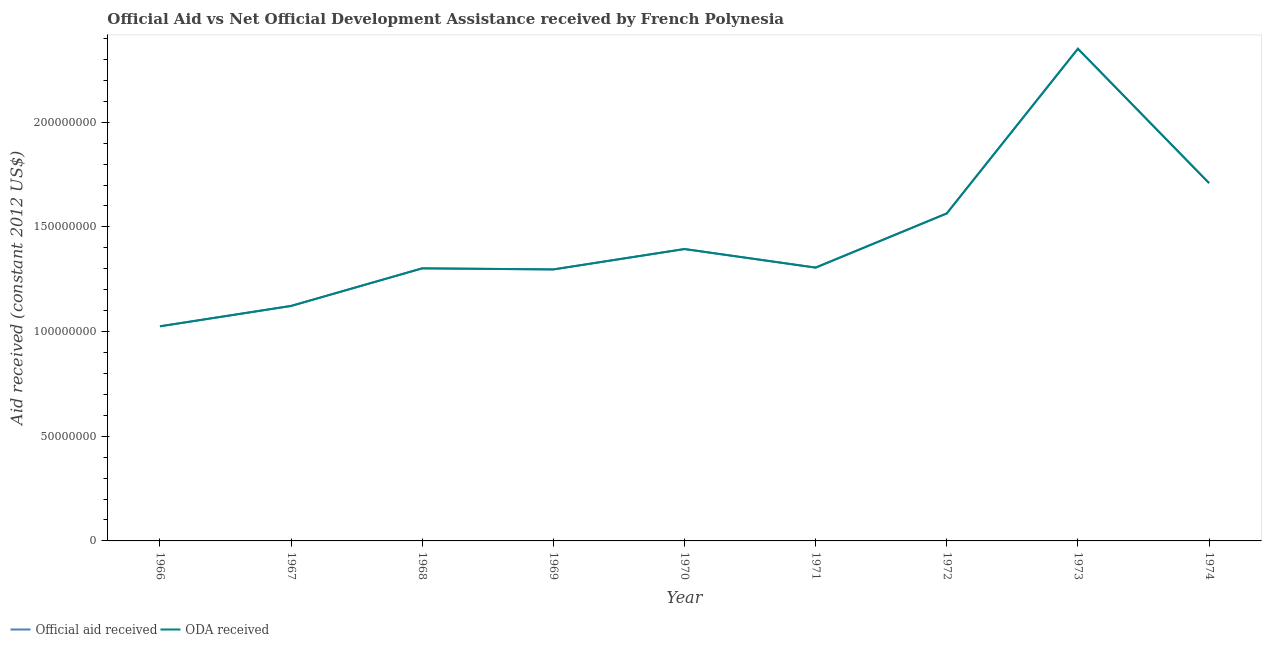How many different coloured lines are there?
Your response must be concise. 2. Does the line corresponding to official aid received intersect with the line corresponding to oda received?
Your response must be concise. Yes. What is the official aid received in 1973?
Your answer should be compact. 2.35e+08. Across all years, what is the maximum official aid received?
Offer a terse response. 2.35e+08. Across all years, what is the minimum official aid received?
Provide a succinct answer. 1.03e+08. In which year was the official aid received minimum?
Keep it short and to the point. 1966. What is the total official aid received in the graph?
Provide a short and direct response. 1.31e+09. What is the difference between the official aid received in 1969 and that in 1972?
Your response must be concise. -2.68e+07. What is the difference between the official aid received in 1969 and the oda received in 1967?
Provide a short and direct response. 1.74e+07. What is the average oda received per year?
Make the answer very short. 1.45e+08. In how many years, is the official aid received greater than 110000000 US$?
Your answer should be compact. 8. What is the ratio of the oda received in 1967 to that in 1969?
Keep it short and to the point. 0.87. Is the official aid received in 1967 less than that in 1969?
Offer a very short reply. Yes. Is the difference between the oda received in 1971 and 1974 greater than the difference between the official aid received in 1971 and 1974?
Offer a terse response. No. What is the difference between the highest and the second highest oda received?
Your answer should be compact. 6.42e+07. What is the difference between the highest and the lowest oda received?
Give a very brief answer. 1.33e+08. Is the oda received strictly greater than the official aid received over the years?
Keep it short and to the point. No. How many lines are there?
Your answer should be very brief. 2. How many years are there in the graph?
Offer a very short reply. 9. What is the difference between two consecutive major ticks on the Y-axis?
Provide a succinct answer. 5.00e+07. Are the values on the major ticks of Y-axis written in scientific E-notation?
Provide a succinct answer. No. Does the graph contain any zero values?
Provide a short and direct response. No. Does the graph contain grids?
Offer a very short reply. No. Where does the legend appear in the graph?
Provide a short and direct response. Bottom left. How many legend labels are there?
Offer a very short reply. 2. What is the title of the graph?
Ensure brevity in your answer.  Official Aid vs Net Official Development Assistance received by French Polynesia . Does "Commercial service exports" appear as one of the legend labels in the graph?
Provide a succinct answer. No. What is the label or title of the X-axis?
Provide a succinct answer. Year. What is the label or title of the Y-axis?
Your answer should be very brief. Aid received (constant 2012 US$). What is the Aid received (constant 2012 US$) of Official aid received in 1966?
Keep it short and to the point. 1.03e+08. What is the Aid received (constant 2012 US$) in ODA received in 1966?
Ensure brevity in your answer.  1.03e+08. What is the Aid received (constant 2012 US$) in Official aid received in 1967?
Offer a terse response. 1.12e+08. What is the Aid received (constant 2012 US$) in ODA received in 1967?
Offer a terse response. 1.12e+08. What is the Aid received (constant 2012 US$) in Official aid received in 1968?
Your response must be concise. 1.30e+08. What is the Aid received (constant 2012 US$) in ODA received in 1968?
Ensure brevity in your answer.  1.30e+08. What is the Aid received (constant 2012 US$) in Official aid received in 1969?
Your answer should be very brief. 1.30e+08. What is the Aid received (constant 2012 US$) in ODA received in 1969?
Your answer should be very brief. 1.30e+08. What is the Aid received (constant 2012 US$) in Official aid received in 1970?
Give a very brief answer. 1.39e+08. What is the Aid received (constant 2012 US$) in ODA received in 1970?
Provide a short and direct response. 1.39e+08. What is the Aid received (constant 2012 US$) of Official aid received in 1971?
Offer a very short reply. 1.31e+08. What is the Aid received (constant 2012 US$) in ODA received in 1971?
Give a very brief answer. 1.31e+08. What is the Aid received (constant 2012 US$) of Official aid received in 1972?
Provide a short and direct response. 1.56e+08. What is the Aid received (constant 2012 US$) in ODA received in 1972?
Give a very brief answer. 1.56e+08. What is the Aid received (constant 2012 US$) in Official aid received in 1973?
Offer a very short reply. 2.35e+08. What is the Aid received (constant 2012 US$) of ODA received in 1973?
Keep it short and to the point. 2.35e+08. What is the Aid received (constant 2012 US$) in Official aid received in 1974?
Ensure brevity in your answer.  1.71e+08. What is the Aid received (constant 2012 US$) of ODA received in 1974?
Your response must be concise. 1.71e+08. Across all years, what is the maximum Aid received (constant 2012 US$) in Official aid received?
Give a very brief answer. 2.35e+08. Across all years, what is the maximum Aid received (constant 2012 US$) of ODA received?
Your response must be concise. 2.35e+08. Across all years, what is the minimum Aid received (constant 2012 US$) in Official aid received?
Your response must be concise. 1.03e+08. Across all years, what is the minimum Aid received (constant 2012 US$) of ODA received?
Your response must be concise. 1.03e+08. What is the total Aid received (constant 2012 US$) of Official aid received in the graph?
Ensure brevity in your answer.  1.31e+09. What is the total Aid received (constant 2012 US$) in ODA received in the graph?
Keep it short and to the point. 1.31e+09. What is the difference between the Aid received (constant 2012 US$) in Official aid received in 1966 and that in 1967?
Ensure brevity in your answer.  -9.73e+06. What is the difference between the Aid received (constant 2012 US$) of ODA received in 1966 and that in 1967?
Provide a succinct answer. -9.73e+06. What is the difference between the Aid received (constant 2012 US$) in Official aid received in 1966 and that in 1968?
Keep it short and to the point. -2.77e+07. What is the difference between the Aid received (constant 2012 US$) in ODA received in 1966 and that in 1968?
Provide a short and direct response. -2.77e+07. What is the difference between the Aid received (constant 2012 US$) of Official aid received in 1966 and that in 1969?
Keep it short and to the point. -2.72e+07. What is the difference between the Aid received (constant 2012 US$) in ODA received in 1966 and that in 1969?
Keep it short and to the point. -2.72e+07. What is the difference between the Aid received (constant 2012 US$) in Official aid received in 1966 and that in 1970?
Give a very brief answer. -3.69e+07. What is the difference between the Aid received (constant 2012 US$) of ODA received in 1966 and that in 1970?
Provide a succinct answer. -3.69e+07. What is the difference between the Aid received (constant 2012 US$) of Official aid received in 1966 and that in 1971?
Keep it short and to the point. -2.80e+07. What is the difference between the Aid received (constant 2012 US$) in ODA received in 1966 and that in 1971?
Provide a succinct answer. -2.80e+07. What is the difference between the Aid received (constant 2012 US$) in Official aid received in 1966 and that in 1972?
Make the answer very short. -5.39e+07. What is the difference between the Aid received (constant 2012 US$) of ODA received in 1966 and that in 1972?
Offer a terse response. -5.39e+07. What is the difference between the Aid received (constant 2012 US$) of Official aid received in 1966 and that in 1973?
Give a very brief answer. -1.33e+08. What is the difference between the Aid received (constant 2012 US$) in ODA received in 1966 and that in 1973?
Offer a very short reply. -1.33e+08. What is the difference between the Aid received (constant 2012 US$) of Official aid received in 1966 and that in 1974?
Your answer should be very brief. -6.84e+07. What is the difference between the Aid received (constant 2012 US$) in ODA received in 1966 and that in 1974?
Your answer should be very brief. -6.84e+07. What is the difference between the Aid received (constant 2012 US$) of Official aid received in 1967 and that in 1968?
Ensure brevity in your answer.  -1.80e+07. What is the difference between the Aid received (constant 2012 US$) in ODA received in 1967 and that in 1968?
Your response must be concise. -1.80e+07. What is the difference between the Aid received (constant 2012 US$) of Official aid received in 1967 and that in 1969?
Make the answer very short. -1.74e+07. What is the difference between the Aid received (constant 2012 US$) in ODA received in 1967 and that in 1969?
Give a very brief answer. -1.74e+07. What is the difference between the Aid received (constant 2012 US$) of Official aid received in 1967 and that in 1970?
Keep it short and to the point. -2.72e+07. What is the difference between the Aid received (constant 2012 US$) of ODA received in 1967 and that in 1970?
Offer a terse response. -2.72e+07. What is the difference between the Aid received (constant 2012 US$) of Official aid received in 1967 and that in 1971?
Your answer should be very brief. -1.83e+07. What is the difference between the Aid received (constant 2012 US$) of ODA received in 1967 and that in 1971?
Your answer should be compact. -1.83e+07. What is the difference between the Aid received (constant 2012 US$) in Official aid received in 1967 and that in 1972?
Keep it short and to the point. -4.42e+07. What is the difference between the Aid received (constant 2012 US$) of ODA received in 1967 and that in 1972?
Provide a succinct answer. -4.42e+07. What is the difference between the Aid received (constant 2012 US$) in Official aid received in 1967 and that in 1973?
Keep it short and to the point. -1.23e+08. What is the difference between the Aid received (constant 2012 US$) in ODA received in 1967 and that in 1973?
Your answer should be very brief. -1.23e+08. What is the difference between the Aid received (constant 2012 US$) of Official aid received in 1967 and that in 1974?
Offer a terse response. -5.87e+07. What is the difference between the Aid received (constant 2012 US$) of ODA received in 1967 and that in 1974?
Make the answer very short. -5.87e+07. What is the difference between the Aid received (constant 2012 US$) of Official aid received in 1968 and that in 1969?
Your answer should be very brief. 5.20e+05. What is the difference between the Aid received (constant 2012 US$) of ODA received in 1968 and that in 1969?
Offer a very short reply. 5.20e+05. What is the difference between the Aid received (constant 2012 US$) of Official aid received in 1968 and that in 1970?
Give a very brief answer. -9.22e+06. What is the difference between the Aid received (constant 2012 US$) in ODA received in 1968 and that in 1970?
Your response must be concise. -9.22e+06. What is the difference between the Aid received (constant 2012 US$) in Official aid received in 1968 and that in 1971?
Your response must be concise. -3.50e+05. What is the difference between the Aid received (constant 2012 US$) in ODA received in 1968 and that in 1971?
Make the answer very short. -3.50e+05. What is the difference between the Aid received (constant 2012 US$) of Official aid received in 1968 and that in 1972?
Your response must be concise. -2.62e+07. What is the difference between the Aid received (constant 2012 US$) in ODA received in 1968 and that in 1972?
Your response must be concise. -2.62e+07. What is the difference between the Aid received (constant 2012 US$) of Official aid received in 1968 and that in 1973?
Offer a terse response. -1.05e+08. What is the difference between the Aid received (constant 2012 US$) in ODA received in 1968 and that in 1973?
Offer a very short reply. -1.05e+08. What is the difference between the Aid received (constant 2012 US$) in Official aid received in 1968 and that in 1974?
Your response must be concise. -4.07e+07. What is the difference between the Aid received (constant 2012 US$) of ODA received in 1968 and that in 1974?
Your answer should be very brief. -4.07e+07. What is the difference between the Aid received (constant 2012 US$) in Official aid received in 1969 and that in 1970?
Your response must be concise. -9.74e+06. What is the difference between the Aid received (constant 2012 US$) in ODA received in 1969 and that in 1970?
Your answer should be very brief. -9.74e+06. What is the difference between the Aid received (constant 2012 US$) in Official aid received in 1969 and that in 1971?
Offer a terse response. -8.70e+05. What is the difference between the Aid received (constant 2012 US$) of ODA received in 1969 and that in 1971?
Offer a very short reply. -8.70e+05. What is the difference between the Aid received (constant 2012 US$) of Official aid received in 1969 and that in 1972?
Your answer should be compact. -2.68e+07. What is the difference between the Aid received (constant 2012 US$) in ODA received in 1969 and that in 1972?
Ensure brevity in your answer.  -2.68e+07. What is the difference between the Aid received (constant 2012 US$) in Official aid received in 1969 and that in 1973?
Your answer should be compact. -1.05e+08. What is the difference between the Aid received (constant 2012 US$) in ODA received in 1969 and that in 1973?
Provide a succinct answer. -1.05e+08. What is the difference between the Aid received (constant 2012 US$) in Official aid received in 1969 and that in 1974?
Ensure brevity in your answer.  -4.12e+07. What is the difference between the Aid received (constant 2012 US$) of ODA received in 1969 and that in 1974?
Give a very brief answer. -4.12e+07. What is the difference between the Aid received (constant 2012 US$) of Official aid received in 1970 and that in 1971?
Your answer should be compact. 8.87e+06. What is the difference between the Aid received (constant 2012 US$) of ODA received in 1970 and that in 1971?
Your answer should be compact. 8.87e+06. What is the difference between the Aid received (constant 2012 US$) of Official aid received in 1970 and that in 1972?
Give a very brief answer. -1.70e+07. What is the difference between the Aid received (constant 2012 US$) of ODA received in 1970 and that in 1972?
Your answer should be very brief. -1.70e+07. What is the difference between the Aid received (constant 2012 US$) of Official aid received in 1970 and that in 1973?
Offer a very short reply. -9.57e+07. What is the difference between the Aid received (constant 2012 US$) in ODA received in 1970 and that in 1973?
Make the answer very short. -9.57e+07. What is the difference between the Aid received (constant 2012 US$) of Official aid received in 1970 and that in 1974?
Your answer should be compact. -3.15e+07. What is the difference between the Aid received (constant 2012 US$) in ODA received in 1970 and that in 1974?
Provide a succinct answer. -3.15e+07. What is the difference between the Aid received (constant 2012 US$) of Official aid received in 1971 and that in 1972?
Offer a very short reply. -2.59e+07. What is the difference between the Aid received (constant 2012 US$) in ODA received in 1971 and that in 1972?
Your answer should be compact. -2.59e+07. What is the difference between the Aid received (constant 2012 US$) of Official aid received in 1971 and that in 1973?
Make the answer very short. -1.05e+08. What is the difference between the Aid received (constant 2012 US$) of ODA received in 1971 and that in 1973?
Your answer should be compact. -1.05e+08. What is the difference between the Aid received (constant 2012 US$) of Official aid received in 1971 and that in 1974?
Give a very brief answer. -4.04e+07. What is the difference between the Aid received (constant 2012 US$) of ODA received in 1971 and that in 1974?
Make the answer very short. -4.04e+07. What is the difference between the Aid received (constant 2012 US$) in Official aid received in 1972 and that in 1973?
Make the answer very short. -7.87e+07. What is the difference between the Aid received (constant 2012 US$) in ODA received in 1972 and that in 1973?
Your answer should be compact. -7.87e+07. What is the difference between the Aid received (constant 2012 US$) of Official aid received in 1972 and that in 1974?
Keep it short and to the point. -1.45e+07. What is the difference between the Aid received (constant 2012 US$) of ODA received in 1972 and that in 1974?
Provide a short and direct response. -1.45e+07. What is the difference between the Aid received (constant 2012 US$) of Official aid received in 1973 and that in 1974?
Make the answer very short. 6.42e+07. What is the difference between the Aid received (constant 2012 US$) of ODA received in 1973 and that in 1974?
Your answer should be compact. 6.42e+07. What is the difference between the Aid received (constant 2012 US$) of Official aid received in 1966 and the Aid received (constant 2012 US$) of ODA received in 1967?
Provide a short and direct response. -9.73e+06. What is the difference between the Aid received (constant 2012 US$) in Official aid received in 1966 and the Aid received (constant 2012 US$) in ODA received in 1968?
Provide a short and direct response. -2.77e+07. What is the difference between the Aid received (constant 2012 US$) in Official aid received in 1966 and the Aid received (constant 2012 US$) in ODA received in 1969?
Your answer should be compact. -2.72e+07. What is the difference between the Aid received (constant 2012 US$) of Official aid received in 1966 and the Aid received (constant 2012 US$) of ODA received in 1970?
Keep it short and to the point. -3.69e+07. What is the difference between the Aid received (constant 2012 US$) of Official aid received in 1966 and the Aid received (constant 2012 US$) of ODA received in 1971?
Offer a terse response. -2.80e+07. What is the difference between the Aid received (constant 2012 US$) of Official aid received in 1966 and the Aid received (constant 2012 US$) of ODA received in 1972?
Your answer should be compact. -5.39e+07. What is the difference between the Aid received (constant 2012 US$) in Official aid received in 1966 and the Aid received (constant 2012 US$) in ODA received in 1973?
Make the answer very short. -1.33e+08. What is the difference between the Aid received (constant 2012 US$) of Official aid received in 1966 and the Aid received (constant 2012 US$) of ODA received in 1974?
Your answer should be compact. -6.84e+07. What is the difference between the Aid received (constant 2012 US$) in Official aid received in 1967 and the Aid received (constant 2012 US$) in ODA received in 1968?
Your response must be concise. -1.80e+07. What is the difference between the Aid received (constant 2012 US$) in Official aid received in 1967 and the Aid received (constant 2012 US$) in ODA received in 1969?
Provide a short and direct response. -1.74e+07. What is the difference between the Aid received (constant 2012 US$) in Official aid received in 1967 and the Aid received (constant 2012 US$) in ODA received in 1970?
Provide a succinct answer. -2.72e+07. What is the difference between the Aid received (constant 2012 US$) of Official aid received in 1967 and the Aid received (constant 2012 US$) of ODA received in 1971?
Make the answer very short. -1.83e+07. What is the difference between the Aid received (constant 2012 US$) of Official aid received in 1967 and the Aid received (constant 2012 US$) of ODA received in 1972?
Your response must be concise. -4.42e+07. What is the difference between the Aid received (constant 2012 US$) in Official aid received in 1967 and the Aid received (constant 2012 US$) in ODA received in 1973?
Provide a succinct answer. -1.23e+08. What is the difference between the Aid received (constant 2012 US$) of Official aid received in 1967 and the Aid received (constant 2012 US$) of ODA received in 1974?
Your answer should be compact. -5.87e+07. What is the difference between the Aid received (constant 2012 US$) in Official aid received in 1968 and the Aid received (constant 2012 US$) in ODA received in 1969?
Keep it short and to the point. 5.20e+05. What is the difference between the Aid received (constant 2012 US$) of Official aid received in 1968 and the Aid received (constant 2012 US$) of ODA received in 1970?
Your answer should be very brief. -9.22e+06. What is the difference between the Aid received (constant 2012 US$) in Official aid received in 1968 and the Aid received (constant 2012 US$) in ODA received in 1971?
Your response must be concise. -3.50e+05. What is the difference between the Aid received (constant 2012 US$) in Official aid received in 1968 and the Aid received (constant 2012 US$) in ODA received in 1972?
Give a very brief answer. -2.62e+07. What is the difference between the Aid received (constant 2012 US$) of Official aid received in 1968 and the Aid received (constant 2012 US$) of ODA received in 1973?
Your response must be concise. -1.05e+08. What is the difference between the Aid received (constant 2012 US$) of Official aid received in 1968 and the Aid received (constant 2012 US$) of ODA received in 1974?
Your answer should be very brief. -4.07e+07. What is the difference between the Aid received (constant 2012 US$) in Official aid received in 1969 and the Aid received (constant 2012 US$) in ODA received in 1970?
Offer a terse response. -9.74e+06. What is the difference between the Aid received (constant 2012 US$) in Official aid received in 1969 and the Aid received (constant 2012 US$) in ODA received in 1971?
Your response must be concise. -8.70e+05. What is the difference between the Aid received (constant 2012 US$) in Official aid received in 1969 and the Aid received (constant 2012 US$) in ODA received in 1972?
Offer a very short reply. -2.68e+07. What is the difference between the Aid received (constant 2012 US$) in Official aid received in 1969 and the Aid received (constant 2012 US$) in ODA received in 1973?
Keep it short and to the point. -1.05e+08. What is the difference between the Aid received (constant 2012 US$) of Official aid received in 1969 and the Aid received (constant 2012 US$) of ODA received in 1974?
Your response must be concise. -4.12e+07. What is the difference between the Aid received (constant 2012 US$) of Official aid received in 1970 and the Aid received (constant 2012 US$) of ODA received in 1971?
Your response must be concise. 8.87e+06. What is the difference between the Aid received (constant 2012 US$) in Official aid received in 1970 and the Aid received (constant 2012 US$) in ODA received in 1972?
Your response must be concise. -1.70e+07. What is the difference between the Aid received (constant 2012 US$) of Official aid received in 1970 and the Aid received (constant 2012 US$) of ODA received in 1973?
Offer a very short reply. -9.57e+07. What is the difference between the Aid received (constant 2012 US$) in Official aid received in 1970 and the Aid received (constant 2012 US$) in ODA received in 1974?
Your answer should be very brief. -3.15e+07. What is the difference between the Aid received (constant 2012 US$) in Official aid received in 1971 and the Aid received (constant 2012 US$) in ODA received in 1972?
Provide a succinct answer. -2.59e+07. What is the difference between the Aid received (constant 2012 US$) in Official aid received in 1971 and the Aid received (constant 2012 US$) in ODA received in 1973?
Ensure brevity in your answer.  -1.05e+08. What is the difference between the Aid received (constant 2012 US$) in Official aid received in 1971 and the Aid received (constant 2012 US$) in ODA received in 1974?
Give a very brief answer. -4.04e+07. What is the difference between the Aid received (constant 2012 US$) in Official aid received in 1972 and the Aid received (constant 2012 US$) in ODA received in 1973?
Offer a very short reply. -7.87e+07. What is the difference between the Aid received (constant 2012 US$) in Official aid received in 1972 and the Aid received (constant 2012 US$) in ODA received in 1974?
Give a very brief answer. -1.45e+07. What is the difference between the Aid received (constant 2012 US$) of Official aid received in 1973 and the Aid received (constant 2012 US$) of ODA received in 1974?
Provide a succinct answer. 6.42e+07. What is the average Aid received (constant 2012 US$) of Official aid received per year?
Make the answer very short. 1.45e+08. What is the average Aid received (constant 2012 US$) of ODA received per year?
Make the answer very short. 1.45e+08. In the year 1969, what is the difference between the Aid received (constant 2012 US$) in Official aid received and Aid received (constant 2012 US$) in ODA received?
Ensure brevity in your answer.  0. In the year 1970, what is the difference between the Aid received (constant 2012 US$) in Official aid received and Aid received (constant 2012 US$) in ODA received?
Offer a very short reply. 0. In the year 1972, what is the difference between the Aid received (constant 2012 US$) in Official aid received and Aid received (constant 2012 US$) in ODA received?
Keep it short and to the point. 0. In the year 1974, what is the difference between the Aid received (constant 2012 US$) in Official aid received and Aid received (constant 2012 US$) in ODA received?
Keep it short and to the point. 0. What is the ratio of the Aid received (constant 2012 US$) of Official aid received in 1966 to that in 1967?
Offer a very short reply. 0.91. What is the ratio of the Aid received (constant 2012 US$) in ODA received in 1966 to that in 1967?
Offer a very short reply. 0.91. What is the ratio of the Aid received (constant 2012 US$) in Official aid received in 1966 to that in 1968?
Ensure brevity in your answer.  0.79. What is the ratio of the Aid received (constant 2012 US$) in ODA received in 1966 to that in 1968?
Keep it short and to the point. 0.79. What is the ratio of the Aid received (constant 2012 US$) in Official aid received in 1966 to that in 1969?
Ensure brevity in your answer.  0.79. What is the ratio of the Aid received (constant 2012 US$) of ODA received in 1966 to that in 1969?
Ensure brevity in your answer.  0.79. What is the ratio of the Aid received (constant 2012 US$) in Official aid received in 1966 to that in 1970?
Provide a succinct answer. 0.74. What is the ratio of the Aid received (constant 2012 US$) of ODA received in 1966 to that in 1970?
Give a very brief answer. 0.74. What is the ratio of the Aid received (constant 2012 US$) of Official aid received in 1966 to that in 1971?
Give a very brief answer. 0.79. What is the ratio of the Aid received (constant 2012 US$) of ODA received in 1966 to that in 1971?
Keep it short and to the point. 0.79. What is the ratio of the Aid received (constant 2012 US$) of Official aid received in 1966 to that in 1972?
Offer a very short reply. 0.66. What is the ratio of the Aid received (constant 2012 US$) of ODA received in 1966 to that in 1972?
Ensure brevity in your answer.  0.66. What is the ratio of the Aid received (constant 2012 US$) in Official aid received in 1966 to that in 1973?
Provide a short and direct response. 0.44. What is the ratio of the Aid received (constant 2012 US$) in ODA received in 1966 to that in 1973?
Give a very brief answer. 0.44. What is the ratio of the Aid received (constant 2012 US$) of Official aid received in 1966 to that in 1974?
Give a very brief answer. 0.6. What is the ratio of the Aid received (constant 2012 US$) in ODA received in 1966 to that in 1974?
Your response must be concise. 0.6. What is the ratio of the Aid received (constant 2012 US$) in Official aid received in 1967 to that in 1968?
Provide a succinct answer. 0.86. What is the ratio of the Aid received (constant 2012 US$) in ODA received in 1967 to that in 1968?
Ensure brevity in your answer.  0.86. What is the ratio of the Aid received (constant 2012 US$) of Official aid received in 1967 to that in 1969?
Offer a very short reply. 0.87. What is the ratio of the Aid received (constant 2012 US$) in ODA received in 1967 to that in 1969?
Your answer should be compact. 0.87. What is the ratio of the Aid received (constant 2012 US$) in Official aid received in 1967 to that in 1970?
Make the answer very short. 0.81. What is the ratio of the Aid received (constant 2012 US$) of ODA received in 1967 to that in 1970?
Offer a terse response. 0.81. What is the ratio of the Aid received (constant 2012 US$) in Official aid received in 1967 to that in 1971?
Offer a terse response. 0.86. What is the ratio of the Aid received (constant 2012 US$) in ODA received in 1967 to that in 1971?
Ensure brevity in your answer.  0.86. What is the ratio of the Aid received (constant 2012 US$) of Official aid received in 1967 to that in 1972?
Your answer should be compact. 0.72. What is the ratio of the Aid received (constant 2012 US$) of ODA received in 1967 to that in 1972?
Make the answer very short. 0.72. What is the ratio of the Aid received (constant 2012 US$) in Official aid received in 1967 to that in 1973?
Ensure brevity in your answer.  0.48. What is the ratio of the Aid received (constant 2012 US$) of ODA received in 1967 to that in 1973?
Keep it short and to the point. 0.48. What is the ratio of the Aid received (constant 2012 US$) of Official aid received in 1967 to that in 1974?
Make the answer very short. 0.66. What is the ratio of the Aid received (constant 2012 US$) of ODA received in 1967 to that in 1974?
Your response must be concise. 0.66. What is the ratio of the Aid received (constant 2012 US$) in Official aid received in 1968 to that in 1969?
Your answer should be compact. 1. What is the ratio of the Aid received (constant 2012 US$) of Official aid received in 1968 to that in 1970?
Offer a terse response. 0.93. What is the ratio of the Aid received (constant 2012 US$) of ODA received in 1968 to that in 1970?
Your answer should be very brief. 0.93. What is the ratio of the Aid received (constant 2012 US$) in ODA received in 1968 to that in 1971?
Keep it short and to the point. 1. What is the ratio of the Aid received (constant 2012 US$) in Official aid received in 1968 to that in 1972?
Make the answer very short. 0.83. What is the ratio of the Aid received (constant 2012 US$) in ODA received in 1968 to that in 1972?
Ensure brevity in your answer.  0.83. What is the ratio of the Aid received (constant 2012 US$) of Official aid received in 1968 to that in 1973?
Make the answer very short. 0.55. What is the ratio of the Aid received (constant 2012 US$) of ODA received in 1968 to that in 1973?
Offer a terse response. 0.55. What is the ratio of the Aid received (constant 2012 US$) in Official aid received in 1968 to that in 1974?
Provide a short and direct response. 0.76. What is the ratio of the Aid received (constant 2012 US$) of ODA received in 1968 to that in 1974?
Provide a succinct answer. 0.76. What is the ratio of the Aid received (constant 2012 US$) of Official aid received in 1969 to that in 1970?
Offer a terse response. 0.93. What is the ratio of the Aid received (constant 2012 US$) in ODA received in 1969 to that in 1970?
Offer a terse response. 0.93. What is the ratio of the Aid received (constant 2012 US$) of Official aid received in 1969 to that in 1972?
Ensure brevity in your answer.  0.83. What is the ratio of the Aid received (constant 2012 US$) of ODA received in 1969 to that in 1972?
Offer a terse response. 0.83. What is the ratio of the Aid received (constant 2012 US$) of Official aid received in 1969 to that in 1973?
Your answer should be compact. 0.55. What is the ratio of the Aid received (constant 2012 US$) of ODA received in 1969 to that in 1973?
Your answer should be compact. 0.55. What is the ratio of the Aid received (constant 2012 US$) in Official aid received in 1969 to that in 1974?
Give a very brief answer. 0.76. What is the ratio of the Aid received (constant 2012 US$) in ODA received in 1969 to that in 1974?
Your response must be concise. 0.76. What is the ratio of the Aid received (constant 2012 US$) in Official aid received in 1970 to that in 1971?
Ensure brevity in your answer.  1.07. What is the ratio of the Aid received (constant 2012 US$) of ODA received in 1970 to that in 1971?
Offer a terse response. 1.07. What is the ratio of the Aid received (constant 2012 US$) in Official aid received in 1970 to that in 1972?
Offer a very short reply. 0.89. What is the ratio of the Aid received (constant 2012 US$) in ODA received in 1970 to that in 1972?
Your answer should be compact. 0.89. What is the ratio of the Aid received (constant 2012 US$) in Official aid received in 1970 to that in 1973?
Ensure brevity in your answer.  0.59. What is the ratio of the Aid received (constant 2012 US$) of ODA received in 1970 to that in 1973?
Provide a short and direct response. 0.59. What is the ratio of the Aid received (constant 2012 US$) of Official aid received in 1970 to that in 1974?
Offer a very short reply. 0.82. What is the ratio of the Aid received (constant 2012 US$) in ODA received in 1970 to that in 1974?
Offer a terse response. 0.82. What is the ratio of the Aid received (constant 2012 US$) of Official aid received in 1971 to that in 1972?
Your response must be concise. 0.83. What is the ratio of the Aid received (constant 2012 US$) in ODA received in 1971 to that in 1972?
Give a very brief answer. 0.83. What is the ratio of the Aid received (constant 2012 US$) in Official aid received in 1971 to that in 1973?
Make the answer very short. 0.56. What is the ratio of the Aid received (constant 2012 US$) of ODA received in 1971 to that in 1973?
Give a very brief answer. 0.56. What is the ratio of the Aid received (constant 2012 US$) of Official aid received in 1971 to that in 1974?
Offer a very short reply. 0.76. What is the ratio of the Aid received (constant 2012 US$) of ODA received in 1971 to that in 1974?
Your answer should be very brief. 0.76. What is the ratio of the Aid received (constant 2012 US$) in Official aid received in 1972 to that in 1973?
Offer a very short reply. 0.67. What is the ratio of the Aid received (constant 2012 US$) of ODA received in 1972 to that in 1973?
Your answer should be compact. 0.67. What is the ratio of the Aid received (constant 2012 US$) of Official aid received in 1972 to that in 1974?
Keep it short and to the point. 0.92. What is the ratio of the Aid received (constant 2012 US$) in ODA received in 1972 to that in 1974?
Your answer should be compact. 0.92. What is the ratio of the Aid received (constant 2012 US$) of Official aid received in 1973 to that in 1974?
Give a very brief answer. 1.38. What is the ratio of the Aid received (constant 2012 US$) of ODA received in 1973 to that in 1974?
Provide a succinct answer. 1.38. What is the difference between the highest and the second highest Aid received (constant 2012 US$) of Official aid received?
Make the answer very short. 6.42e+07. What is the difference between the highest and the second highest Aid received (constant 2012 US$) of ODA received?
Provide a succinct answer. 6.42e+07. What is the difference between the highest and the lowest Aid received (constant 2012 US$) in Official aid received?
Provide a succinct answer. 1.33e+08. What is the difference between the highest and the lowest Aid received (constant 2012 US$) in ODA received?
Offer a very short reply. 1.33e+08. 